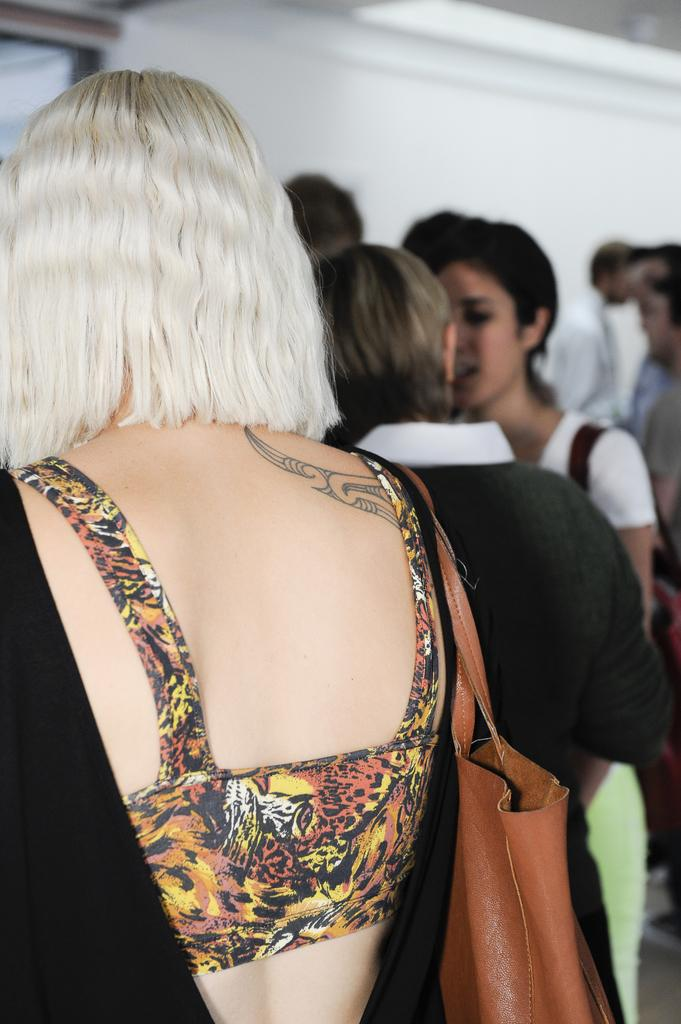What can be seen in the image? There is a group of people in the image. How are the people dressed? The people are wearing different color dresses. What are some people holding in the image? There are people with bags in the image. What is the color of the background in the image? The background of the image is white. What type of thread is being used to sew the dresses in the image? There is no information about the type of thread used to sew the dresses in the image. 